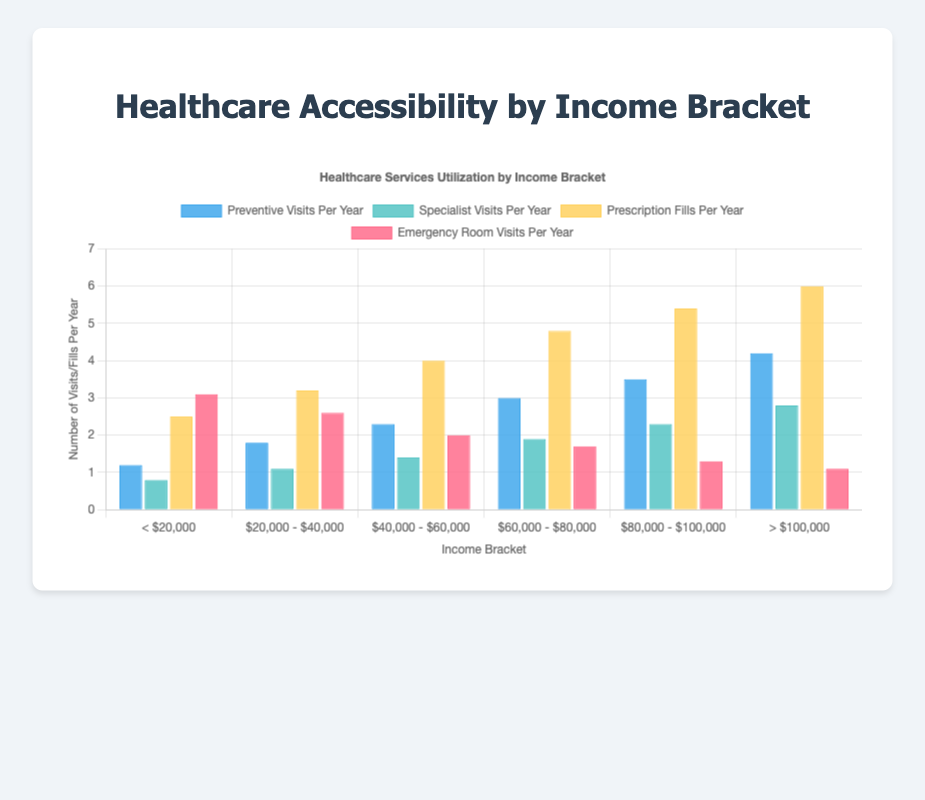What income bracket has the highest number of preventive visits per year? Looking at the height of the blue bars for preventive visits, the tallest bar corresponds to the "> $100,000" income bracket.
Answer: > $100,000 Which income bracket has the lowest emergency room visits per year? Observing the height of the red bars for emergency room visits, the shortest bar is for the "> $100,000" income bracket.
Answer: > $100,000 By how much does the number of specialist visits per year increase from the "$20,000 - $40,000" bracket to the "$60,000 - $80,000" bracket? The number of specialist visits for "$20,000 - $40,000" is 1.1, and for "$60,000 - $80,000" is 1.9. The difference is 1.9 - 1.1 = 0.8.
Answer: 0.8 What is the average number of prescription fills per year for the income brackets "$40,000 - $60,000" and "$60,000 - $80,000"? Summing the prescription fills for these brackets: 4.0 (for $40,000 - $60,000) + 4.8 (for $60,000 - $80,000) = 8.8. The average is 8.8 / 2 = 4.4.
Answer: 4.4 Which income bracket has a higher number of preventive visits per year, "$20,000 - $40,000" or "$40,000 - $60,000"? The preventive visits are 1.8 for "$20,000 - $40,000" and 2.3 for "$40,000 - $60,000". Since 2.3 > 1.8, the "$40,000 - $60,000" bracket has a higher number.
Answer: $40,000 - $60,000 Are there any income brackets where the number of preventive visits per year is greater than the number of specialist visits per year? For all income brackets, the height of the blue bars (preventive visits) is greater than the height of the light green bars (specialist visits).
Answer: Yes What is the sum of preventive visits per year for the "< $20,000" and "> $100,000" income brackets? The number of preventive visits is 1.2 for "< $20,000" and 4.2 for "> $100,000". Summing these values: 1.2 + 4.2 = 5.4.
Answer: 5.4 